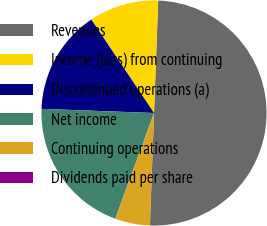Convert chart to OTSL. <chart><loc_0><loc_0><loc_500><loc_500><pie_chart><fcel>Revenues<fcel>Income (loss) from continuing<fcel>Discontinued operations (a)<fcel>Net income<fcel>Continuing operations<fcel>Dividends paid per share<nl><fcel>49.99%<fcel>10.0%<fcel>15.0%<fcel>20.0%<fcel>5.0%<fcel>0.0%<nl></chart> 